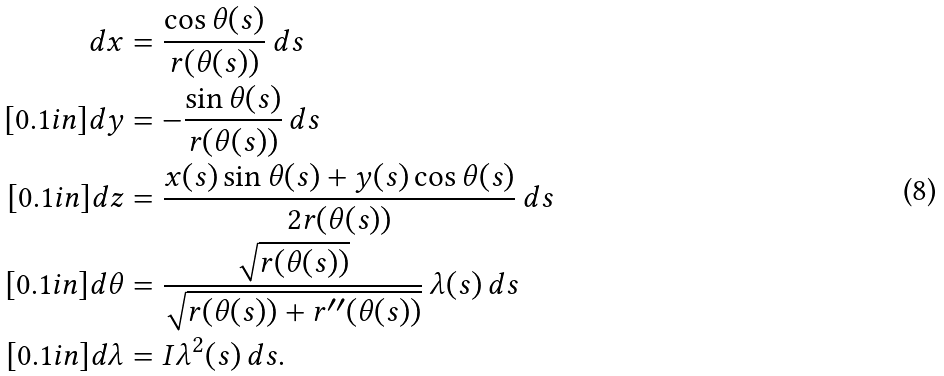Convert formula to latex. <formula><loc_0><loc_0><loc_500><loc_500>d x & = \frac { \cos \theta ( s ) } { r ( \theta ( s ) ) } \, d s \\ [ 0 . 1 i n ] d y & = - \frac { \sin \theta ( s ) } { r ( \theta ( s ) ) } \, d s \\ [ 0 . 1 i n ] d z & = \frac { x ( s ) \sin \theta ( s ) + y ( s ) \cos \theta ( s ) } { 2 r ( \theta ( s ) ) } \, d s \\ [ 0 . 1 i n ] d \theta & = \frac { \sqrt { r ( \theta ( s ) ) } } { \sqrt { r ( \theta ( s ) ) + r ^ { \prime \prime } ( \theta ( s ) ) } } \, \lambda ( s ) \, d s \\ [ 0 . 1 i n ] d \lambda & = I \lambda ^ { 2 } ( s ) \, d s .</formula> 